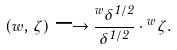<formula> <loc_0><loc_0><loc_500><loc_500>( w , \zeta ) \longrightarrow \frac { { ^ { w } } \delta ^ { 1 / 2 } } { \delta ^ { 1 / 2 } } \cdot { ^ { w } } \zeta .</formula> 